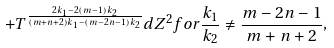<formula> <loc_0><loc_0><loc_500><loc_500>+ T ^ { \frac { 2 k _ { 1 } - 2 ( m - 1 ) k _ { 2 } } { ( m + n + 2 ) k _ { 1 } - ( m - 2 n - 1 ) k _ { 2 } } } d Z ^ { 2 } f o r \frac { k _ { 1 } } { k _ { 2 } } \ne \frac { m - 2 n - 1 } { m + n + 2 } ,</formula> 